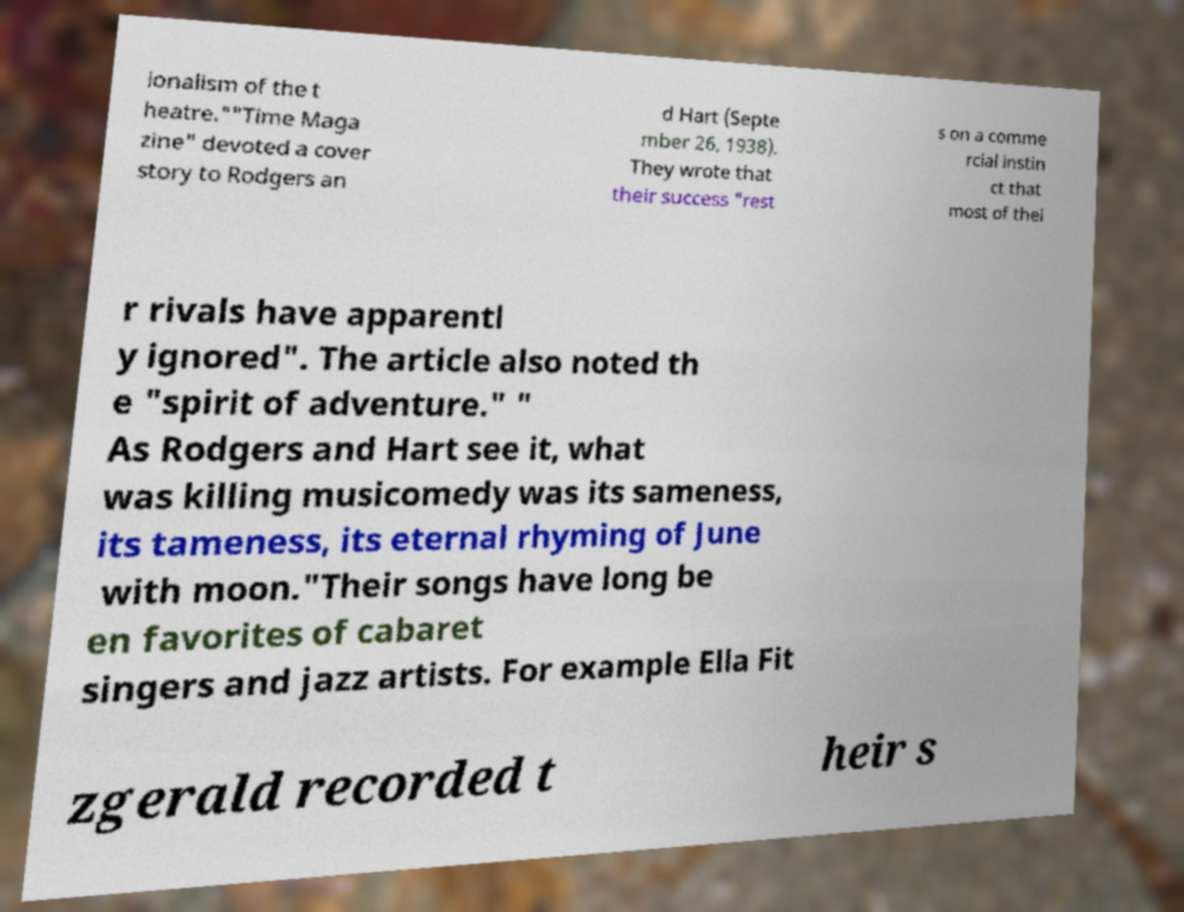There's text embedded in this image that I need extracted. Can you transcribe it verbatim? ionalism of the t heatre.""Time Maga zine" devoted a cover story to Rodgers an d Hart (Septe mber 26, 1938). They wrote that their success "rest s on a comme rcial instin ct that most of thei r rivals have apparentl y ignored". The article also noted th e "spirit of adventure." " As Rodgers and Hart see it, what was killing musicomedy was its sameness, its tameness, its eternal rhyming of June with moon."Their songs have long be en favorites of cabaret singers and jazz artists. For example Ella Fit zgerald recorded t heir s 